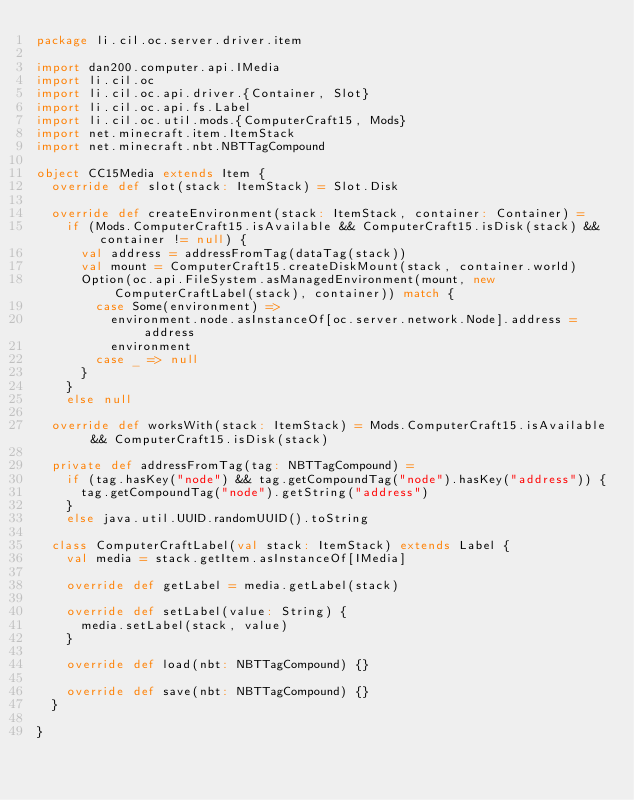Convert code to text. <code><loc_0><loc_0><loc_500><loc_500><_Scala_>package li.cil.oc.server.driver.item

import dan200.computer.api.IMedia
import li.cil.oc
import li.cil.oc.api.driver.{Container, Slot}
import li.cil.oc.api.fs.Label
import li.cil.oc.util.mods.{ComputerCraft15, Mods}
import net.minecraft.item.ItemStack
import net.minecraft.nbt.NBTTagCompound

object CC15Media extends Item {
  override def slot(stack: ItemStack) = Slot.Disk

  override def createEnvironment(stack: ItemStack, container: Container) =
    if (Mods.ComputerCraft15.isAvailable && ComputerCraft15.isDisk(stack) && container != null) {
      val address = addressFromTag(dataTag(stack))
      val mount = ComputerCraft15.createDiskMount(stack, container.world)
      Option(oc.api.FileSystem.asManagedEnvironment(mount, new ComputerCraftLabel(stack), container)) match {
        case Some(environment) =>
          environment.node.asInstanceOf[oc.server.network.Node].address = address
          environment
        case _ => null
      }
    }
    else null

  override def worksWith(stack: ItemStack) = Mods.ComputerCraft15.isAvailable && ComputerCraft15.isDisk(stack)

  private def addressFromTag(tag: NBTTagCompound) =
    if (tag.hasKey("node") && tag.getCompoundTag("node").hasKey("address")) {
      tag.getCompoundTag("node").getString("address")
    }
    else java.util.UUID.randomUUID().toString

  class ComputerCraftLabel(val stack: ItemStack) extends Label {
    val media = stack.getItem.asInstanceOf[IMedia]

    override def getLabel = media.getLabel(stack)

    override def setLabel(value: String) {
      media.setLabel(stack, value)
    }

    override def load(nbt: NBTTagCompound) {}

    override def save(nbt: NBTTagCompound) {}
  }

}
</code> 